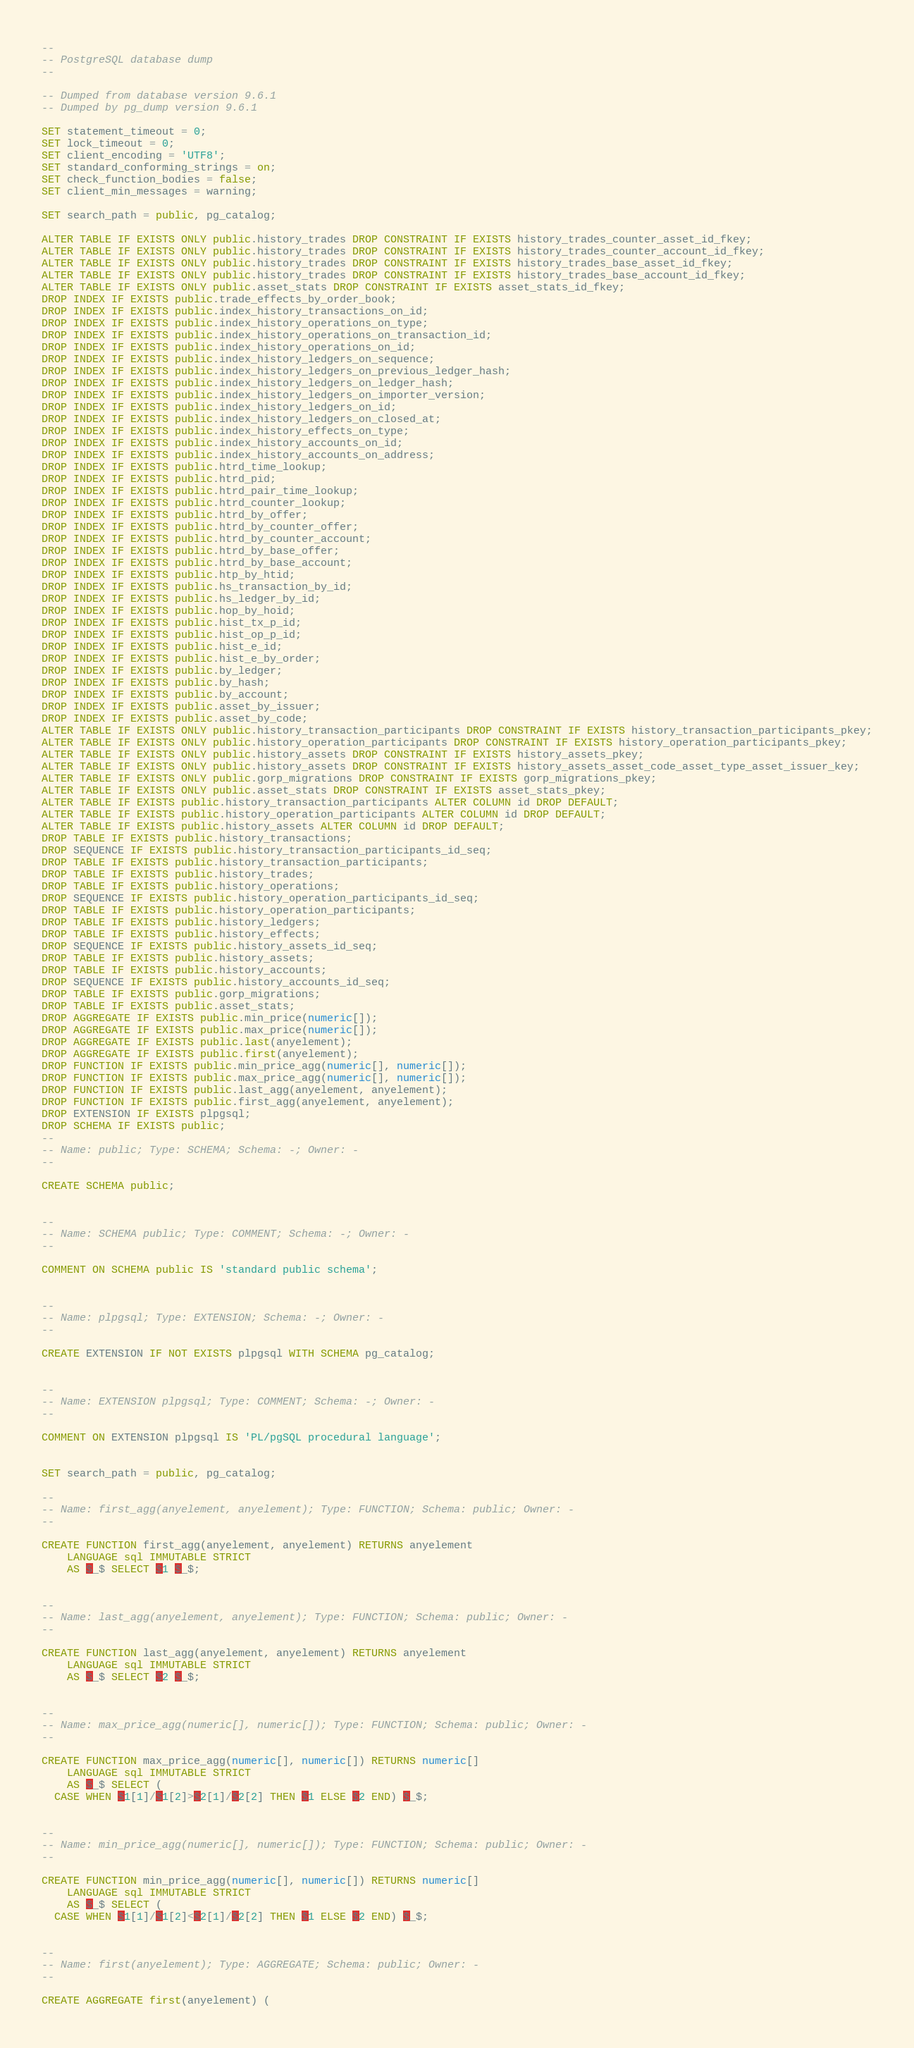Convert code to text. <code><loc_0><loc_0><loc_500><loc_500><_SQL_>--
-- PostgreSQL database dump
--

-- Dumped from database version 9.6.1
-- Dumped by pg_dump version 9.6.1

SET statement_timeout = 0;
SET lock_timeout = 0;
SET client_encoding = 'UTF8';
SET standard_conforming_strings = on;
SET check_function_bodies = false;
SET client_min_messages = warning;

SET search_path = public, pg_catalog;

ALTER TABLE IF EXISTS ONLY public.history_trades DROP CONSTRAINT IF EXISTS history_trades_counter_asset_id_fkey;
ALTER TABLE IF EXISTS ONLY public.history_trades DROP CONSTRAINT IF EXISTS history_trades_counter_account_id_fkey;
ALTER TABLE IF EXISTS ONLY public.history_trades DROP CONSTRAINT IF EXISTS history_trades_base_asset_id_fkey;
ALTER TABLE IF EXISTS ONLY public.history_trades DROP CONSTRAINT IF EXISTS history_trades_base_account_id_fkey;
ALTER TABLE IF EXISTS ONLY public.asset_stats DROP CONSTRAINT IF EXISTS asset_stats_id_fkey;
DROP INDEX IF EXISTS public.trade_effects_by_order_book;
DROP INDEX IF EXISTS public.index_history_transactions_on_id;
DROP INDEX IF EXISTS public.index_history_operations_on_type;
DROP INDEX IF EXISTS public.index_history_operations_on_transaction_id;
DROP INDEX IF EXISTS public.index_history_operations_on_id;
DROP INDEX IF EXISTS public.index_history_ledgers_on_sequence;
DROP INDEX IF EXISTS public.index_history_ledgers_on_previous_ledger_hash;
DROP INDEX IF EXISTS public.index_history_ledgers_on_ledger_hash;
DROP INDEX IF EXISTS public.index_history_ledgers_on_importer_version;
DROP INDEX IF EXISTS public.index_history_ledgers_on_id;
DROP INDEX IF EXISTS public.index_history_ledgers_on_closed_at;
DROP INDEX IF EXISTS public.index_history_effects_on_type;
DROP INDEX IF EXISTS public.index_history_accounts_on_id;
DROP INDEX IF EXISTS public.index_history_accounts_on_address;
DROP INDEX IF EXISTS public.htrd_time_lookup;
DROP INDEX IF EXISTS public.htrd_pid;
DROP INDEX IF EXISTS public.htrd_pair_time_lookup;
DROP INDEX IF EXISTS public.htrd_counter_lookup;
DROP INDEX IF EXISTS public.htrd_by_offer;
DROP INDEX IF EXISTS public.htrd_by_counter_offer;
DROP INDEX IF EXISTS public.htrd_by_counter_account;
DROP INDEX IF EXISTS public.htrd_by_base_offer;
DROP INDEX IF EXISTS public.htrd_by_base_account;
DROP INDEX IF EXISTS public.htp_by_htid;
DROP INDEX IF EXISTS public.hs_transaction_by_id;
DROP INDEX IF EXISTS public.hs_ledger_by_id;
DROP INDEX IF EXISTS public.hop_by_hoid;
DROP INDEX IF EXISTS public.hist_tx_p_id;
DROP INDEX IF EXISTS public.hist_op_p_id;
DROP INDEX IF EXISTS public.hist_e_id;
DROP INDEX IF EXISTS public.hist_e_by_order;
DROP INDEX IF EXISTS public.by_ledger;
DROP INDEX IF EXISTS public.by_hash;
DROP INDEX IF EXISTS public.by_account;
DROP INDEX IF EXISTS public.asset_by_issuer;
DROP INDEX IF EXISTS public.asset_by_code;
ALTER TABLE IF EXISTS ONLY public.history_transaction_participants DROP CONSTRAINT IF EXISTS history_transaction_participants_pkey;
ALTER TABLE IF EXISTS ONLY public.history_operation_participants DROP CONSTRAINT IF EXISTS history_operation_participants_pkey;
ALTER TABLE IF EXISTS ONLY public.history_assets DROP CONSTRAINT IF EXISTS history_assets_pkey;
ALTER TABLE IF EXISTS ONLY public.history_assets DROP CONSTRAINT IF EXISTS history_assets_asset_code_asset_type_asset_issuer_key;
ALTER TABLE IF EXISTS ONLY public.gorp_migrations DROP CONSTRAINT IF EXISTS gorp_migrations_pkey;
ALTER TABLE IF EXISTS ONLY public.asset_stats DROP CONSTRAINT IF EXISTS asset_stats_pkey;
ALTER TABLE IF EXISTS public.history_transaction_participants ALTER COLUMN id DROP DEFAULT;
ALTER TABLE IF EXISTS public.history_operation_participants ALTER COLUMN id DROP DEFAULT;
ALTER TABLE IF EXISTS public.history_assets ALTER COLUMN id DROP DEFAULT;
DROP TABLE IF EXISTS public.history_transactions;
DROP SEQUENCE IF EXISTS public.history_transaction_participants_id_seq;
DROP TABLE IF EXISTS public.history_transaction_participants;
DROP TABLE IF EXISTS public.history_trades;
DROP TABLE IF EXISTS public.history_operations;
DROP SEQUENCE IF EXISTS public.history_operation_participants_id_seq;
DROP TABLE IF EXISTS public.history_operation_participants;
DROP TABLE IF EXISTS public.history_ledgers;
DROP TABLE IF EXISTS public.history_effects;
DROP SEQUENCE IF EXISTS public.history_assets_id_seq;
DROP TABLE IF EXISTS public.history_assets;
DROP TABLE IF EXISTS public.history_accounts;
DROP SEQUENCE IF EXISTS public.history_accounts_id_seq;
DROP TABLE IF EXISTS public.gorp_migrations;
DROP TABLE IF EXISTS public.asset_stats;
DROP AGGREGATE IF EXISTS public.min_price(numeric[]);
DROP AGGREGATE IF EXISTS public.max_price(numeric[]);
DROP AGGREGATE IF EXISTS public.last(anyelement);
DROP AGGREGATE IF EXISTS public.first(anyelement);
DROP FUNCTION IF EXISTS public.min_price_agg(numeric[], numeric[]);
DROP FUNCTION IF EXISTS public.max_price_agg(numeric[], numeric[]);
DROP FUNCTION IF EXISTS public.last_agg(anyelement, anyelement);
DROP FUNCTION IF EXISTS public.first_agg(anyelement, anyelement);
DROP EXTENSION IF EXISTS plpgsql;
DROP SCHEMA IF EXISTS public;
--
-- Name: public; Type: SCHEMA; Schema: -; Owner: -
--

CREATE SCHEMA public;


--
-- Name: SCHEMA public; Type: COMMENT; Schema: -; Owner: -
--

COMMENT ON SCHEMA public IS 'standard public schema';


--
-- Name: plpgsql; Type: EXTENSION; Schema: -; Owner: -
--

CREATE EXTENSION IF NOT EXISTS plpgsql WITH SCHEMA pg_catalog;


--
-- Name: EXTENSION plpgsql; Type: COMMENT; Schema: -; Owner: -
--

COMMENT ON EXTENSION plpgsql IS 'PL/pgSQL procedural language';


SET search_path = public, pg_catalog;

--
-- Name: first_agg(anyelement, anyelement); Type: FUNCTION; Schema: public; Owner: -
--

CREATE FUNCTION first_agg(anyelement, anyelement) RETURNS anyelement
    LANGUAGE sql IMMUTABLE STRICT
    AS $_$ SELECT $1 $_$;


--
-- Name: last_agg(anyelement, anyelement); Type: FUNCTION; Schema: public; Owner: -
--

CREATE FUNCTION last_agg(anyelement, anyelement) RETURNS anyelement
    LANGUAGE sql IMMUTABLE STRICT
    AS $_$ SELECT $2 $_$;


--
-- Name: max_price_agg(numeric[], numeric[]); Type: FUNCTION; Schema: public; Owner: -
--

CREATE FUNCTION max_price_agg(numeric[], numeric[]) RETURNS numeric[]
    LANGUAGE sql IMMUTABLE STRICT
    AS $_$ SELECT (
  CASE WHEN $1[1]/$1[2]>$2[1]/$2[2] THEN $1 ELSE $2 END) $_$;


--
-- Name: min_price_agg(numeric[], numeric[]); Type: FUNCTION; Schema: public; Owner: -
--

CREATE FUNCTION min_price_agg(numeric[], numeric[]) RETURNS numeric[]
    LANGUAGE sql IMMUTABLE STRICT
    AS $_$ SELECT (
  CASE WHEN $1[1]/$1[2]<$2[1]/$2[2] THEN $1 ELSE $2 END) $_$;


--
-- Name: first(anyelement); Type: AGGREGATE; Schema: public; Owner: -
--

CREATE AGGREGATE first(anyelement) (</code> 